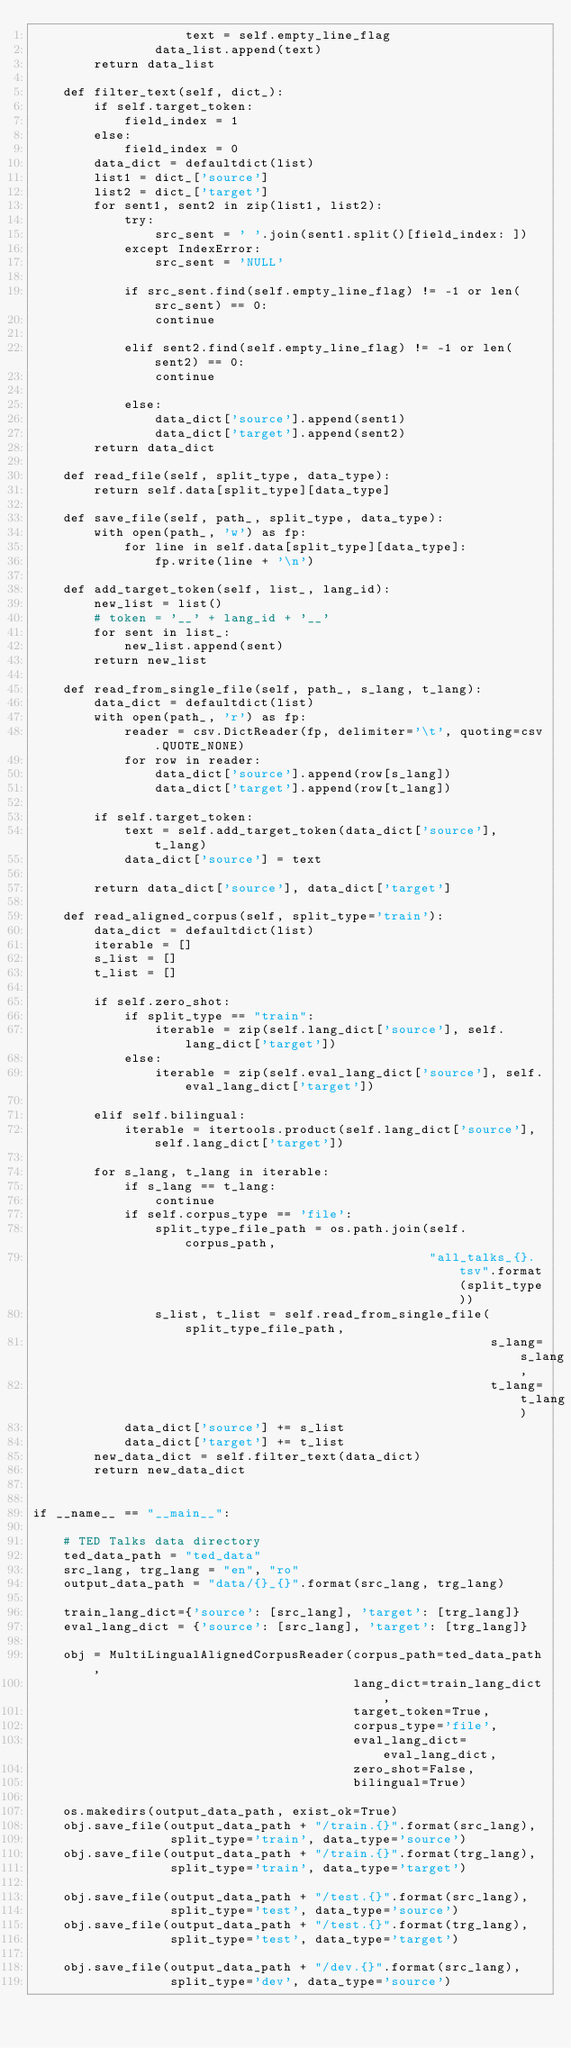Convert code to text. <code><loc_0><loc_0><loc_500><loc_500><_Python_>                    text = self.empty_line_flag
                data_list.append(text)
        return data_list

    def filter_text(self, dict_):
        if self.target_token:
            field_index = 1
        else:
            field_index = 0
        data_dict = defaultdict(list)
        list1 = dict_['source']
        list2 = dict_['target']
        for sent1, sent2 in zip(list1, list2):
            try:
                src_sent = ' '.join(sent1.split()[field_index: ])
            except IndexError:
                src_sent = 'NULL'

            if src_sent.find(self.empty_line_flag) != -1 or len(src_sent) == 0:
                continue

            elif sent2.find(self.empty_line_flag) != -1 or len(sent2) == 0:
                continue

            else:
                data_dict['source'].append(sent1)
                data_dict['target'].append(sent2)
        return data_dict

    def read_file(self, split_type, data_type):
        return self.data[split_type][data_type]

    def save_file(self, path_, split_type, data_type):
        with open(path_, 'w') as fp:
            for line in self.data[split_type][data_type]:
                fp.write(line + '\n')

    def add_target_token(self, list_, lang_id):
        new_list = list()
        # token = '__' + lang_id + '__'
        for sent in list_:
            new_list.append(sent)
        return new_list

    def read_from_single_file(self, path_, s_lang, t_lang):
        data_dict = defaultdict(list)
        with open(path_, 'r') as fp:
            reader = csv.DictReader(fp, delimiter='\t', quoting=csv.QUOTE_NONE)
            for row in reader:
                data_dict['source'].append(row[s_lang])
                data_dict['target'].append(row[t_lang])

        if self.target_token:
            text = self.add_target_token(data_dict['source'], t_lang)
            data_dict['source'] = text

        return data_dict['source'], data_dict['target']

    def read_aligned_corpus(self, split_type='train'):
        data_dict = defaultdict(list)
        iterable = []
        s_list = []
        t_list = []

        if self.zero_shot:
            if split_type == "train":
                iterable = zip(self.lang_dict['source'], self.lang_dict['target'])
            else:
                iterable = zip(self.eval_lang_dict['source'], self.eval_lang_dict['target'])

        elif self.bilingual:
            iterable = itertools.product(self.lang_dict['source'], self.lang_dict['target'])

        for s_lang, t_lang in iterable:
            if s_lang == t_lang:
                continue
            if self.corpus_type == 'file':
                split_type_file_path = os.path.join(self.corpus_path,
                                                    "all_talks_{}.tsv".format(split_type))
                s_list, t_list = self.read_from_single_file(split_type_file_path,
                                                            s_lang=s_lang,
                                                            t_lang=t_lang)
            data_dict['source'] += s_list
            data_dict['target'] += t_list
        new_data_dict = self.filter_text(data_dict)
        return new_data_dict


if __name__ == "__main__":

    # TED Talks data directory
    ted_data_path = "ted_data"
    src_lang, trg_lang = "en", "ro"
    output_data_path = "data/{}_{}".format(src_lang, trg_lang)

    train_lang_dict={'source': [src_lang], 'target': [trg_lang]}
    eval_lang_dict = {'source': [src_lang], 'target': [trg_lang]}

    obj = MultiLingualAlignedCorpusReader(corpus_path=ted_data_path,
                                          lang_dict=train_lang_dict,
                                          target_token=True,
                                          corpus_type='file',
                                          eval_lang_dict=eval_lang_dict,
                                          zero_shot=False,
                                          bilingual=True)

    os.makedirs(output_data_path, exist_ok=True)
    obj.save_file(output_data_path + "/train.{}".format(src_lang),
                  split_type='train', data_type='source')
    obj.save_file(output_data_path + "/train.{}".format(trg_lang),
                  split_type='train', data_type='target')

    obj.save_file(output_data_path + "/test.{}".format(src_lang),
                  split_type='test', data_type='source')
    obj.save_file(output_data_path + "/test.{}".format(trg_lang),
                  split_type='test', data_type='target')

    obj.save_file(output_data_path + "/dev.{}".format(src_lang),
                  split_type='dev', data_type='source')</code> 